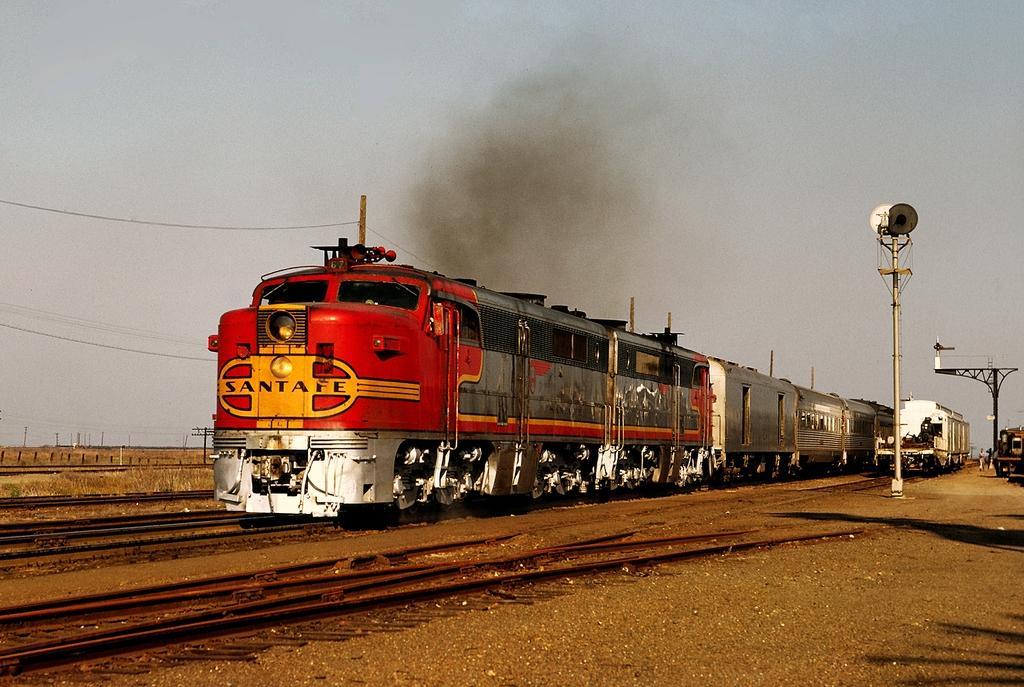How would you summarize this image in a sentence or two? In this image I can see few railway tracks and on it I can see train. In background I can see few poles, smoke, wires, shadows and the sky. 